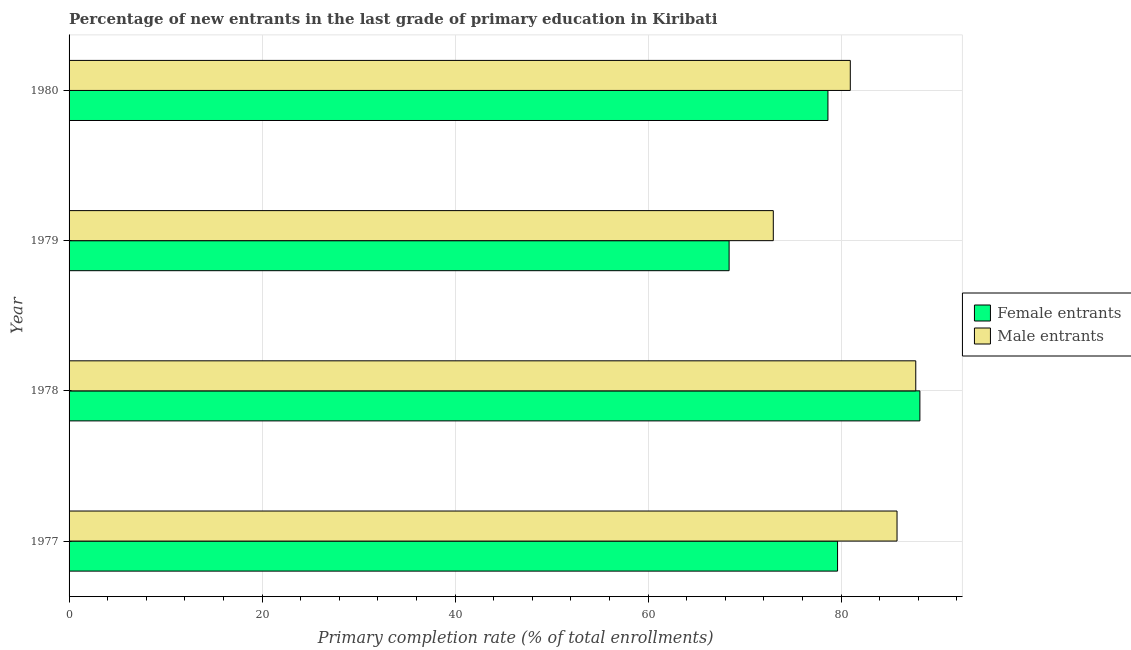What is the label of the 3rd group of bars from the top?
Your response must be concise. 1978. In how many cases, is the number of bars for a given year not equal to the number of legend labels?
Make the answer very short. 0. What is the primary completion rate of male entrants in 1978?
Offer a very short reply. 87.74. Across all years, what is the maximum primary completion rate of male entrants?
Ensure brevity in your answer.  87.74. Across all years, what is the minimum primary completion rate of female entrants?
Offer a very short reply. 68.39. In which year was the primary completion rate of female entrants maximum?
Keep it short and to the point. 1978. In which year was the primary completion rate of female entrants minimum?
Keep it short and to the point. 1979. What is the total primary completion rate of male entrants in the graph?
Ensure brevity in your answer.  327.46. What is the difference between the primary completion rate of male entrants in 1978 and that in 1979?
Give a very brief answer. 14.76. What is the difference between the primary completion rate of male entrants in 1978 and the primary completion rate of female entrants in 1977?
Provide a short and direct response. 8.1. What is the average primary completion rate of male entrants per year?
Offer a very short reply. 81.86. In the year 1979, what is the difference between the primary completion rate of male entrants and primary completion rate of female entrants?
Give a very brief answer. 4.58. In how many years, is the primary completion rate of male entrants greater than 60 %?
Your response must be concise. 4. What is the ratio of the primary completion rate of male entrants in 1977 to that in 1980?
Ensure brevity in your answer.  1.06. Is the difference between the primary completion rate of female entrants in 1977 and 1979 greater than the difference between the primary completion rate of male entrants in 1977 and 1979?
Give a very brief answer. No. What is the difference between the highest and the second highest primary completion rate of male entrants?
Keep it short and to the point. 1.94. What is the difference between the highest and the lowest primary completion rate of female entrants?
Keep it short and to the point. 19.77. In how many years, is the primary completion rate of male entrants greater than the average primary completion rate of male entrants taken over all years?
Make the answer very short. 2. What does the 1st bar from the top in 1980 represents?
Offer a very short reply. Male entrants. What does the 2nd bar from the bottom in 1978 represents?
Keep it short and to the point. Male entrants. How many years are there in the graph?
Your response must be concise. 4. What is the difference between two consecutive major ticks on the X-axis?
Provide a short and direct response. 20. Does the graph contain any zero values?
Provide a succinct answer. No. Does the graph contain grids?
Offer a very short reply. Yes. Where does the legend appear in the graph?
Your answer should be compact. Center right. What is the title of the graph?
Ensure brevity in your answer.  Percentage of new entrants in the last grade of primary education in Kiribati. Does "Arms exports" appear as one of the legend labels in the graph?
Give a very brief answer. No. What is the label or title of the X-axis?
Provide a short and direct response. Primary completion rate (% of total enrollments). What is the label or title of the Y-axis?
Keep it short and to the point. Year. What is the Primary completion rate (% of total enrollments) of Female entrants in 1977?
Provide a succinct answer. 79.63. What is the Primary completion rate (% of total enrollments) in Male entrants in 1977?
Provide a short and direct response. 85.79. What is the Primary completion rate (% of total enrollments) in Female entrants in 1978?
Give a very brief answer. 88.16. What is the Primary completion rate (% of total enrollments) in Male entrants in 1978?
Give a very brief answer. 87.74. What is the Primary completion rate (% of total enrollments) of Female entrants in 1979?
Give a very brief answer. 68.39. What is the Primary completion rate (% of total enrollments) in Male entrants in 1979?
Offer a terse response. 72.97. What is the Primary completion rate (% of total enrollments) in Female entrants in 1980?
Your answer should be compact. 78.63. What is the Primary completion rate (% of total enrollments) in Male entrants in 1980?
Keep it short and to the point. 80.95. Across all years, what is the maximum Primary completion rate (% of total enrollments) in Female entrants?
Offer a terse response. 88.16. Across all years, what is the maximum Primary completion rate (% of total enrollments) of Male entrants?
Keep it short and to the point. 87.74. Across all years, what is the minimum Primary completion rate (% of total enrollments) in Female entrants?
Give a very brief answer. 68.39. Across all years, what is the minimum Primary completion rate (% of total enrollments) of Male entrants?
Make the answer very short. 72.97. What is the total Primary completion rate (% of total enrollments) of Female entrants in the graph?
Ensure brevity in your answer.  314.82. What is the total Primary completion rate (% of total enrollments) in Male entrants in the graph?
Your answer should be very brief. 327.46. What is the difference between the Primary completion rate (% of total enrollments) in Female entrants in 1977 and that in 1978?
Provide a succinct answer. -8.53. What is the difference between the Primary completion rate (% of total enrollments) in Male entrants in 1977 and that in 1978?
Offer a terse response. -1.94. What is the difference between the Primary completion rate (% of total enrollments) of Female entrants in 1977 and that in 1979?
Your response must be concise. 11.24. What is the difference between the Primary completion rate (% of total enrollments) in Male entrants in 1977 and that in 1979?
Ensure brevity in your answer.  12.82. What is the difference between the Primary completion rate (% of total enrollments) in Female entrants in 1977 and that in 1980?
Keep it short and to the point. 1. What is the difference between the Primary completion rate (% of total enrollments) in Male entrants in 1977 and that in 1980?
Offer a terse response. 4.84. What is the difference between the Primary completion rate (% of total enrollments) of Female entrants in 1978 and that in 1979?
Your response must be concise. 19.77. What is the difference between the Primary completion rate (% of total enrollments) of Male entrants in 1978 and that in 1979?
Make the answer very short. 14.76. What is the difference between the Primary completion rate (% of total enrollments) of Female entrants in 1978 and that in 1980?
Make the answer very short. 9.53. What is the difference between the Primary completion rate (% of total enrollments) of Male entrants in 1978 and that in 1980?
Provide a succinct answer. 6.78. What is the difference between the Primary completion rate (% of total enrollments) of Female entrants in 1979 and that in 1980?
Give a very brief answer. -10.24. What is the difference between the Primary completion rate (% of total enrollments) of Male entrants in 1979 and that in 1980?
Offer a terse response. -7.98. What is the difference between the Primary completion rate (% of total enrollments) in Female entrants in 1977 and the Primary completion rate (% of total enrollments) in Male entrants in 1978?
Provide a short and direct response. -8.1. What is the difference between the Primary completion rate (% of total enrollments) of Female entrants in 1977 and the Primary completion rate (% of total enrollments) of Male entrants in 1979?
Your answer should be very brief. 6.66. What is the difference between the Primary completion rate (% of total enrollments) of Female entrants in 1977 and the Primary completion rate (% of total enrollments) of Male entrants in 1980?
Give a very brief answer. -1.32. What is the difference between the Primary completion rate (% of total enrollments) of Female entrants in 1978 and the Primary completion rate (% of total enrollments) of Male entrants in 1979?
Offer a terse response. 15.19. What is the difference between the Primary completion rate (% of total enrollments) of Female entrants in 1978 and the Primary completion rate (% of total enrollments) of Male entrants in 1980?
Provide a short and direct response. 7.21. What is the difference between the Primary completion rate (% of total enrollments) of Female entrants in 1979 and the Primary completion rate (% of total enrollments) of Male entrants in 1980?
Give a very brief answer. -12.56. What is the average Primary completion rate (% of total enrollments) in Female entrants per year?
Keep it short and to the point. 78.71. What is the average Primary completion rate (% of total enrollments) in Male entrants per year?
Provide a short and direct response. 81.86. In the year 1977, what is the difference between the Primary completion rate (% of total enrollments) in Female entrants and Primary completion rate (% of total enrollments) in Male entrants?
Your answer should be very brief. -6.16. In the year 1978, what is the difference between the Primary completion rate (% of total enrollments) of Female entrants and Primary completion rate (% of total enrollments) of Male entrants?
Make the answer very short. 0.43. In the year 1979, what is the difference between the Primary completion rate (% of total enrollments) of Female entrants and Primary completion rate (% of total enrollments) of Male entrants?
Your answer should be very brief. -4.58. In the year 1980, what is the difference between the Primary completion rate (% of total enrollments) in Female entrants and Primary completion rate (% of total enrollments) in Male entrants?
Give a very brief answer. -2.32. What is the ratio of the Primary completion rate (% of total enrollments) in Female entrants in 1977 to that in 1978?
Keep it short and to the point. 0.9. What is the ratio of the Primary completion rate (% of total enrollments) of Male entrants in 1977 to that in 1978?
Keep it short and to the point. 0.98. What is the ratio of the Primary completion rate (% of total enrollments) in Female entrants in 1977 to that in 1979?
Provide a short and direct response. 1.16. What is the ratio of the Primary completion rate (% of total enrollments) of Male entrants in 1977 to that in 1979?
Ensure brevity in your answer.  1.18. What is the ratio of the Primary completion rate (% of total enrollments) of Female entrants in 1977 to that in 1980?
Provide a short and direct response. 1.01. What is the ratio of the Primary completion rate (% of total enrollments) of Male entrants in 1977 to that in 1980?
Your response must be concise. 1.06. What is the ratio of the Primary completion rate (% of total enrollments) in Female entrants in 1978 to that in 1979?
Provide a short and direct response. 1.29. What is the ratio of the Primary completion rate (% of total enrollments) in Male entrants in 1978 to that in 1979?
Provide a short and direct response. 1.2. What is the ratio of the Primary completion rate (% of total enrollments) in Female entrants in 1978 to that in 1980?
Offer a very short reply. 1.12. What is the ratio of the Primary completion rate (% of total enrollments) of Male entrants in 1978 to that in 1980?
Provide a succinct answer. 1.08. What is the ratio of the Primary completion rate (% of total enrollments) of Female entrants in 1979 to that in 1980?
Your answer should be very brief. 0.87. What is the ratio of the Primary completion rate (% of total enrollments) of Male entrants in 1979 to that in 1980?
Your response must be concise. 0.9. What is the difference between the highest and the second highest Primary completion rate (% of total enrollments) of Female entrants?
Your answer should be very brief. 8.53. What is the difference between the highest and the second highest Primary completion rate (% of total enrollments) in Male entrants?
Your answer should be compact. 1.94. What is the difference between the highest and the lowest Primary completion rate (% of total enrollments) in Female entrants?
Keep it short and to the point. 19.77. What is the difference between the highest and the lowest Primary completion rate (% of total enrollments) of Male entrants?
Your answer should be very brief. 14.76. 